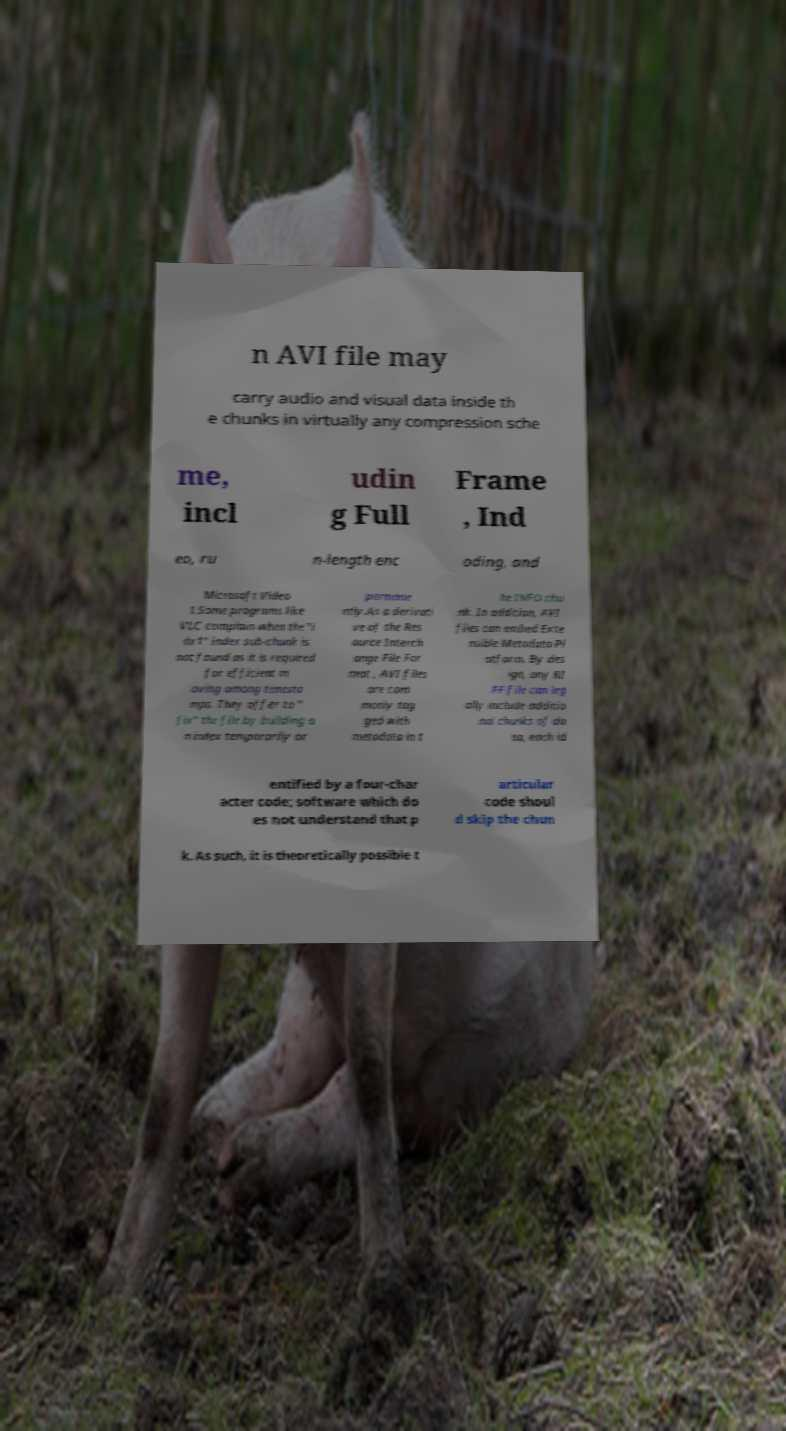Could you assist in decoding the text presented in this image and type it out clearly? n AVI file may carry audio and visual data inside th e chunks in virtually any compression sche me, incl udin g Full Frame , Ind eo, ru n-length enc oding, and Microsoft Video 1.Some programs like VLC complain when the "i dx1" index sub-chunk is not found as it is required for efficient m oving among timesta mps. They offer to " fix" the file by building a n index temporarily or permane ntly.As a derivati ve of the Res ource Interch ange File For mat , AVI files are com monly tag ged with metadata in t he INFO chu nk. In addition, AVI files can embed Exte nsible Metadata Pl atform. By des ign, any RI FF file can leg ally include additio nal chunks of da ta, each id entified by a four-char acter code; software which do es not understand that p articular code shoul d skip the chun k. As such, it is theoretically possible t 